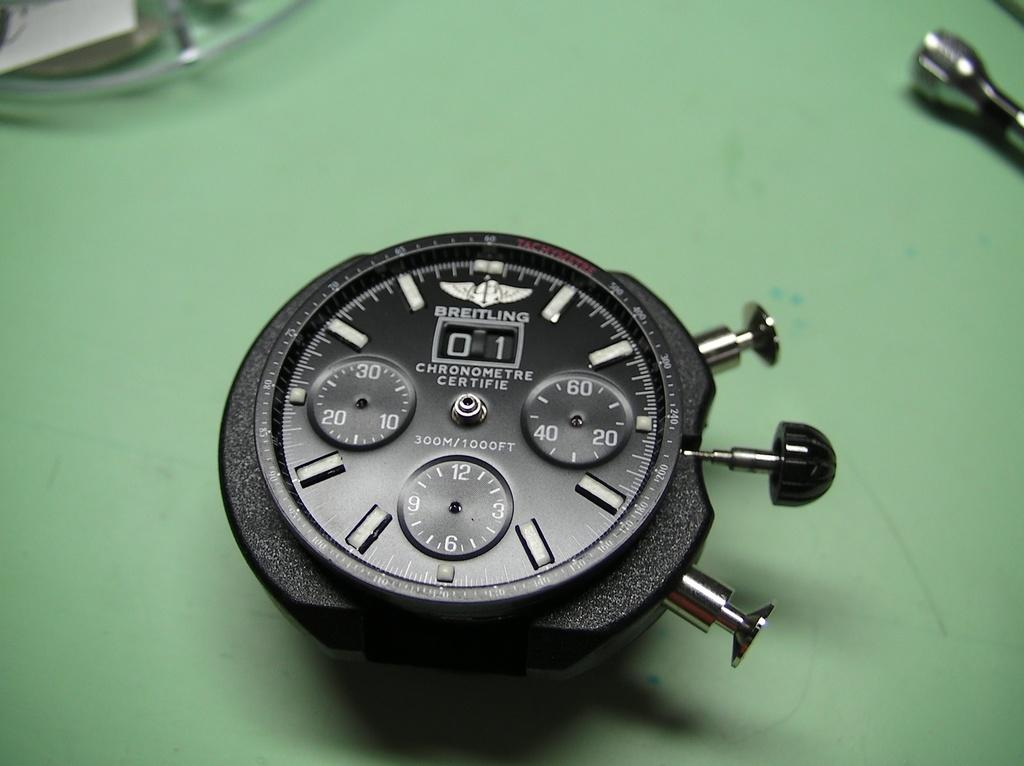<image>
Write a terse but informative summary of the picture. A Breitling watch sits on a green table and has three buttons on the side. 